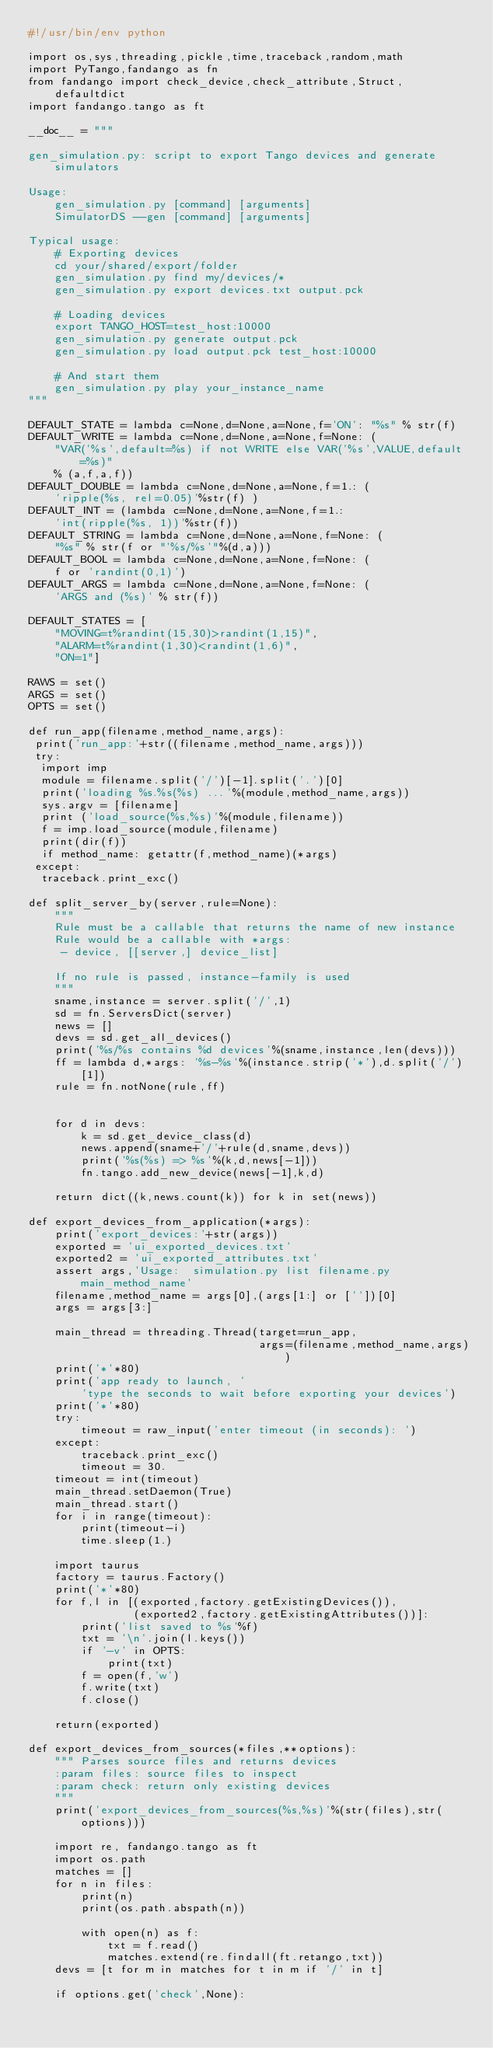<code> <loc_0><loc_0><loc_500><loc_500><_Python_>#!/usr/bin/env python

import os,sys,threading,pickle,time,traceback,random,math
import PyTango,fandango as fn
from fandango import check_device,check_attribute,Struct,defaultdict
import fandango.tango as ft

__doc__ = """

gen_simulation.py: script to export Tango devices and generate simulators

Usage:
    gen_simulation.py [command] [arguments]
    SimulatorDS --gen [command] [arguments]
    
Typical usage:
    # Exporting devices
    cd your/shared/export/folder
    gen_simulation.py find my/devices/*
    gen_simulation.py export devices.txt output.pck
    
    # Loading devices
    export TANGO_HOST=test_host:10000
    gen_simulation.py generate output.pck
    gen_simulation.py load output.pck test_host:10000
    
    # And start them
    gen_simulation.py play your_instance_name
"""

DEFAULT_STATE = lambda c=None,d=None,a=None,f='ON': "%s" % str(f)
DEFAULT_WRITE = lambda c=None,d=None,a=None,f=None: (
    "VAR('%s',default=%s) if not WRITE else VAR('%s',VALUE,default=%s)" 
    % (a,f,a,f))
DEFAULT_DOUBLE = lambda c=None,d=None,a=None,f=1.: (
    'ripple(%s, rel=0.05)'%str(f) )
DEFAULT_INT = (lambda c=None,d=None,a=None,f=1.: 
    'int(ripple(%s, 1))'%str(f))
DEFAULT_STRING = lambda c=None,d=None,a=None,f=None: ( 
    "%s" % str(f or "'%s/%s'"%(d,a)))
DEFAULT_BOOL = lambda c=None,d=None,a=None,f=None: (
    f or 'randint(0,1)')
DEFAULT_ARGS = lambda c=None,d=None,a=None,f=None: (
    'ARGS and (%s)' % str(f))

DEFAULT_STATES = [
    "MOVING=t%randint(15,30)>randint(1,15)",
    "ALARM=t%randint(1,30)<randint(1,6)",
    "ON=1"]

RAWS = set()
ARGS = set()
OPTS = set()

def run_app(filename,method_name,args):
 print('run_app:'+str((filename,method_name,args)))
 try:
  import imp
  module = filename.split('/')[-1].split('.')[0]
  print('loading %s.%s(%s) ...'%(module,method_name,args))
  sys.argv = [filename]
  print ('load_source(%s,%s)'%(module,filename))
  f = imp.load_source(module,filename)
  print(dir(f))
  if method_name: getattr(f,method_name)(*args)
 except:
  traceback.print_exc()
  
def split_server_by(server,rule=None):
    """
    Rule must be a callable that returns the name of new instance
    Rule would be a callable with *args:
     - device, [[server,] device_list]

    If no rule is passed, instance-family is used
    """
    sname,instance = server.split('/',1)
    sd = fn.ServersDict(server)
    news = []
    devs = sd.get_all_devices()
    print('%s/%s contains %d devices'%(sname,instance,len(devs)))
    ff = lambda d,*args: '%s-%s'%(instance.strip('*'),d.split('/')[1])
    rule = fn.notNone(rule,ff)
        
        
    for d in devs:
        k = sd.get_device_class(d)
        news.append(sname+'/'+rule(d,sname,devs))
        print('%s(%s) => %s'%(k,d,news[-1]))
        fn.tango.add_new_device(news[-1],k,d)
        
    return dict((k,news.count(k)) for k in set(news))

def export_devices_from_application(*args):
    print('export_devices:'+str(args))
    exported = 'ui_exported_devices.txt'
    exported2 = 'ui_exported_attributes.txt'
    assert args,'Usage:  simulation.py list filename.py main_method_name'
    filename,method_name = args[0],(args[1:] or [''])[0]
    args = args[3:]

    main_thread = threading.Thread(target=run_app,
                                   args=(filename,method_name,args))
    print('*'*80)
    print('app ready to launch, '
        'type the seconds to wait before exporting your devices')
    print('*'*80)
    try:
        timeout = raw_input('enter timeout (in seconds): ')
    except:
        traceback.print_exc()
        timeout = 30.
    timeout = int(timeout)
    main_thread.setDaemon(True)
    main_thread.start()
    for i in range(timeout): 
        print(timeout-i)
        time.sleep(1.)

    import taurus
    factory = taurus.Factory()
    print('*'*80)
    for f,l in [(exported,factory.getExistingDevices()),
                (exported2,factory.getExistingAttributes())]:
        print('list saved to %s'%f)
        txt = '\n'.join(l.keys())
        if '-v' in OPTS:
            print(txt)
        f = open(f,'w')
        f.write(txt)
        f.close()
            
    return(exported)

def export_devices_from_sources(*files,**options):
    """ Parses source files and returns devices
    :param files: source files to inspect
    :param check: return only existing devices
    """
    print('export_devices_from_sources(%s,%s)'%(str(files),str(options)))
    
    import re, fandango.tango as ft
    import os.path
    matches = []
    for n in files:
        print(n)
        print(os.path.abspath(n))
        
        with open(n) as f:
            txt = f.read()
            matches.extend(re.findall(ft.retango,txt))
    devs = [t for m in matches for t in m if '/' in t]

    if options.get('check',None):</code> 